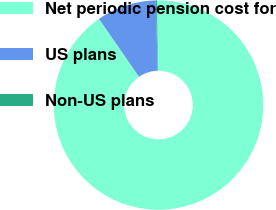<chart> <loc_0><loc_0><loc_500><loc_500><pie_chart><fcel>Net periodic pension cost for<fcel>US plans<fcel>Non-US plans<nl><fcel>90.62%<fcel>9.21%<fcel>0.17%<nl></chart> 